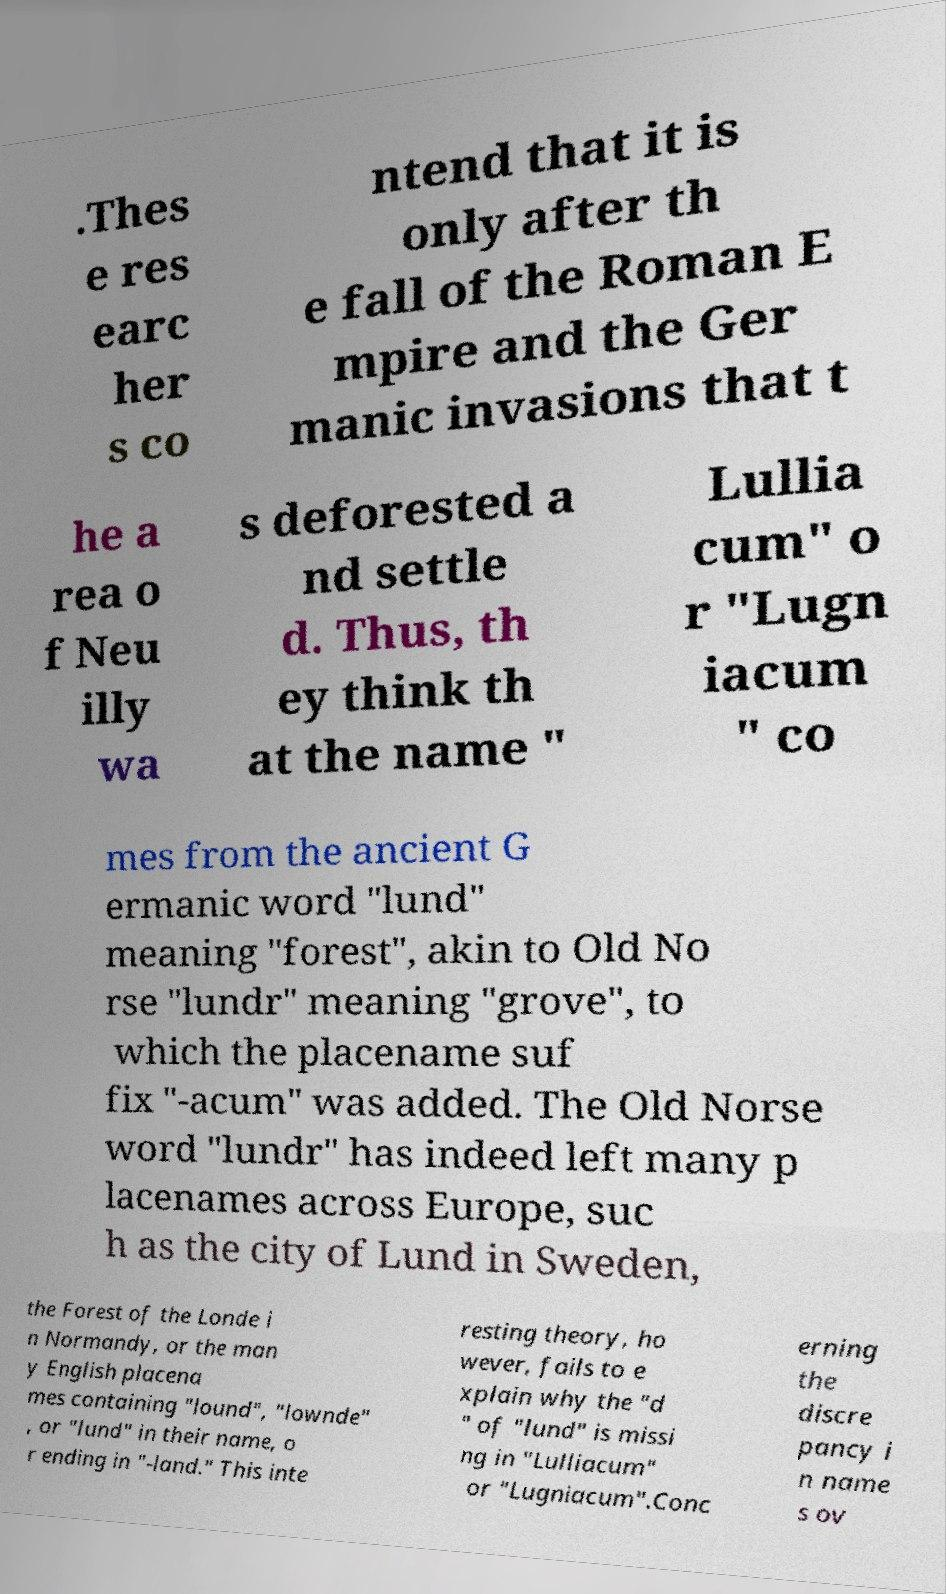Please read and relay the text visible in this image. What does it say? .Thes e res earc her s co ntend that it is only after th e fall of the Roman E mpire and the Ger manic invasions that t he a rea o f Neu illy wa s deforested a nd settle d. Thus, th ey think th at the name " Lullia cum" o r "Lugn iacum " co mes from the ancient G ermanic word "lund" meaning "forest", akin to Old No rse "lundr" meaning "grove", to which the placename suf fix "-acum" was added. The Old Norse word "lundr" has indeed left many p lacenames across Europe, suc h as the city of Lund in Sweden, the Forest of the Londe i n Normandy, or the man y English placena mes containing "lound", "lownde" , or "lund" in their name, o r ending in "-land." This inte resting theory, ho wever, fails to e xplain why the "d " of "lund" is missi ng in "Lulliacum" or "Lugniacum".Conc erning the discre pancy i n name s ov 